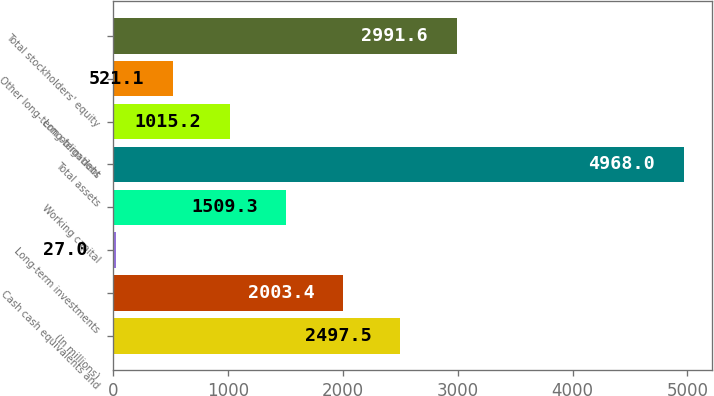Convert chart to OTSL. <chart><loc_0><loc_0><loc_500><loc_500><bar_chart><fcel>(In millions)<fcel>Cash cash equivalents and<fcel>Long-term investments<fcel>Working capital<fcel>Total assets<fcel>Long-term debt<fcel>Other long-term obligations<fcel>Total stockholders' equity<nl><fcel>2497.5<fcel>2003.4<fcel>27<fcel>1509.3<fcel>4968<fcel>1015.2<fcel>521.1<fcel>2991.6<nl></chart> 